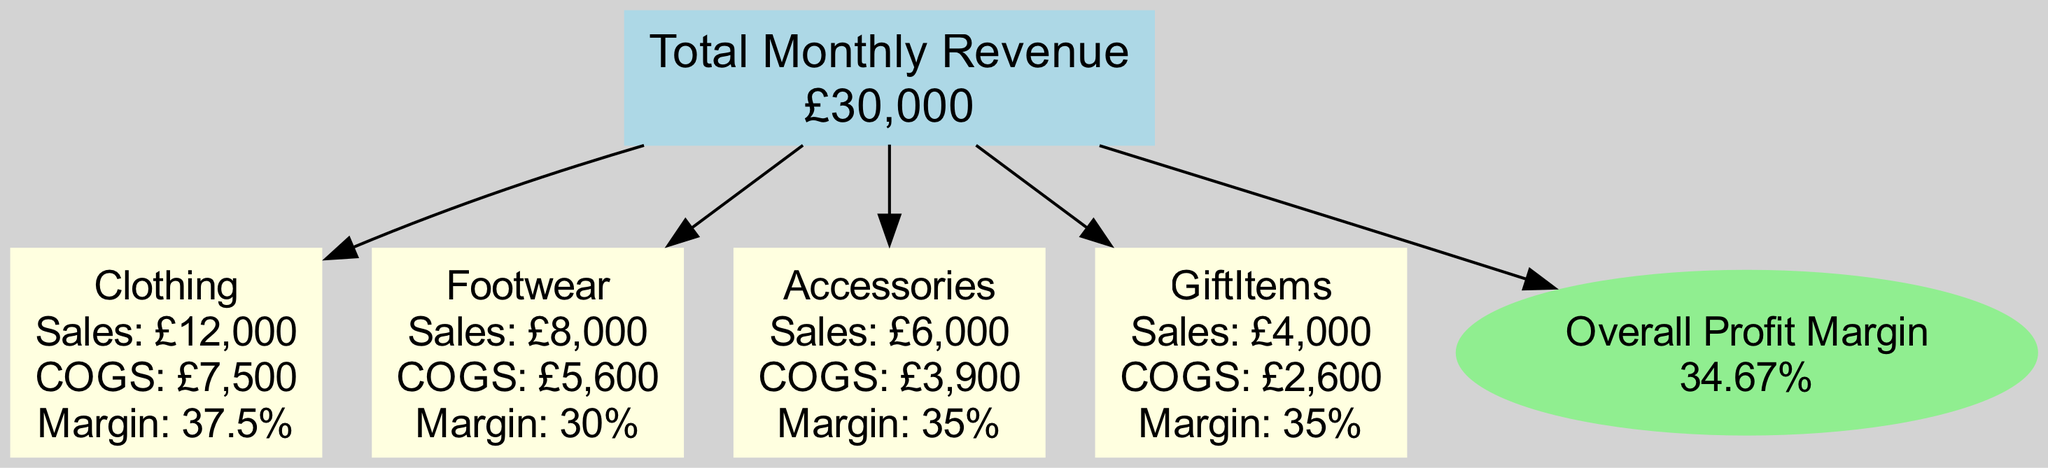What is the total monthly revenue? The diagram explicitly states the total monthly revenue at the main node, which is £30,000.
Answer: £30,000 Which category has the highest sales? By examining the sales figures detailed in each category node, Clothing has the highest sales at £12,000.
Answer: Clothing What is the profit margin for footwear? The footwear category node indicates a profit margin of 30%.
Answer: 30% How many categories are there in the revenue breakdown? The diagram features four category nodes—Clothing, Footwear, Accessories, and Gift Items—indicating that there are four categories.
Answer: 4 What is the total cost of goods sold? The total cost of goods sold is directly stated in the diagram as £19,600, positioned at the main node's connection to the profit margin node.
Answer: £19,600 Which category has the lowest profit margin? By comparing the profit margins from the respective category nodes, Footwear with 30% has the lowest profit margin among the listed categories.
Answer: Footwear What is the overall profit margin? The overall profit margin displayed at the profit node in the diagram is 34.67%, providing an average across all categories.
Answer: 34.67% Which category is associated with a sales figure of £6,000? The Accessories category node indicates a sales figure of £6,000.
Answer: Accessories What is the relationship between the total monthly revenue and the categories? The total monthly revenue node serves as the main parent node, with each category connected as children, showing that each category contributes to the overall revenue.
Answer: Parent-child relationship 